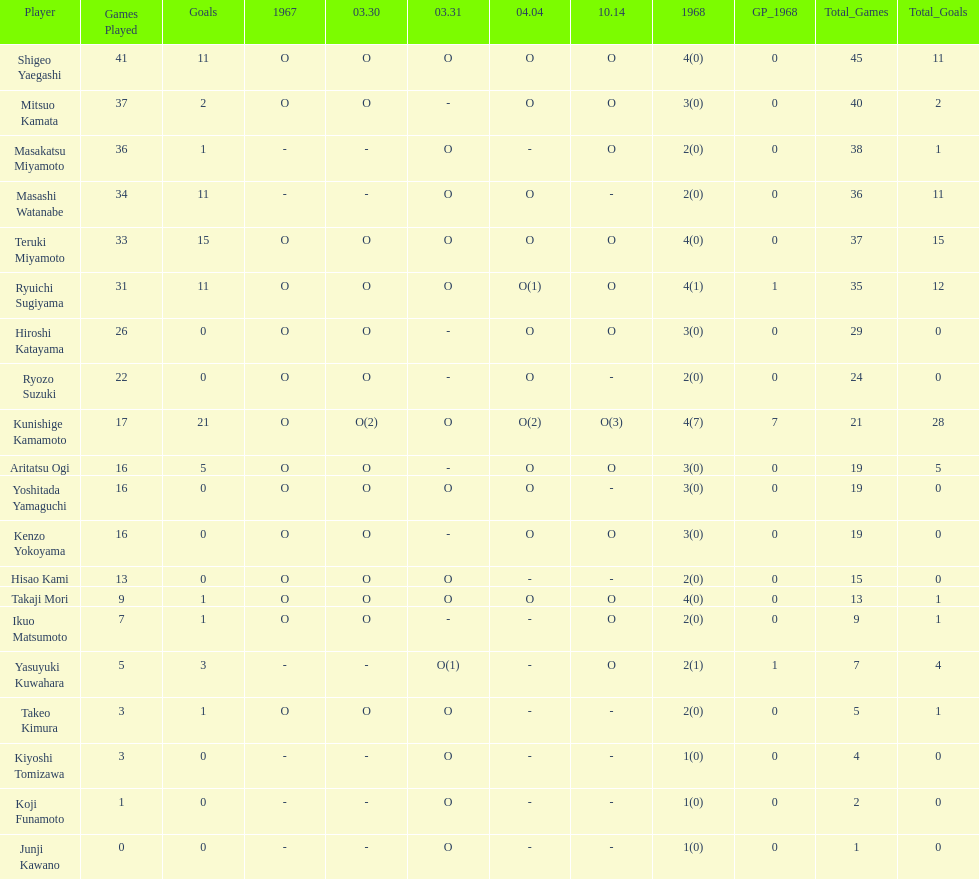Did mitsuo kamata have more than 40 total points? No. 